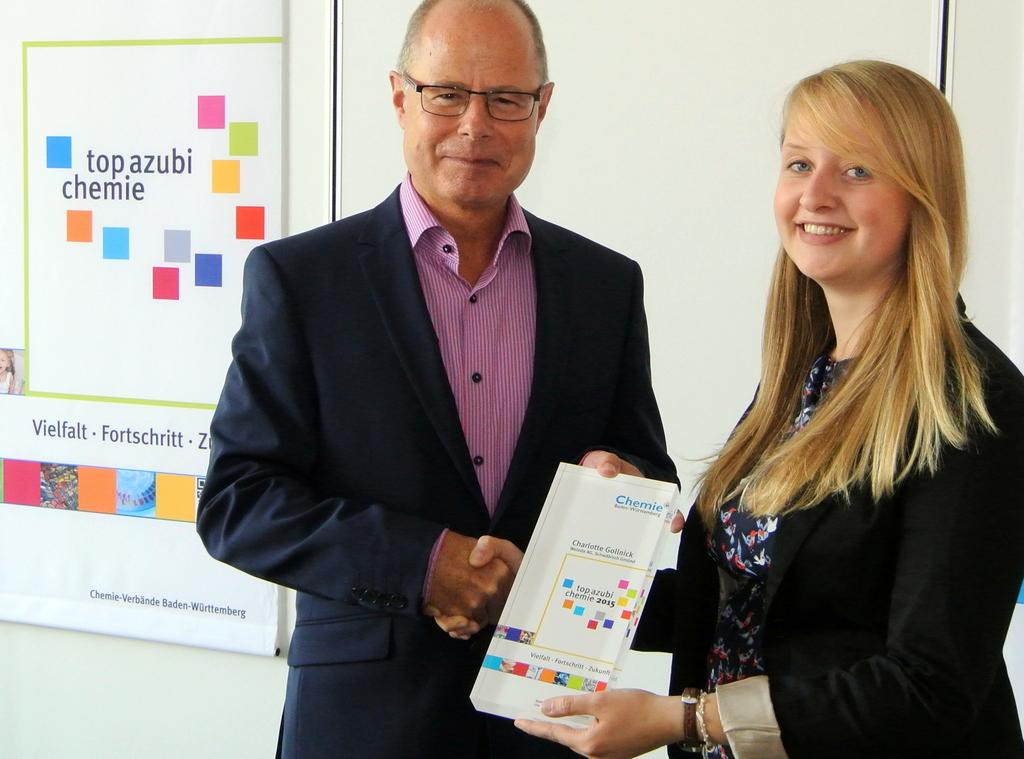How many people are in the image? There are two people in the image. What are the two people doing in the image? The two people are holding a board and shaking hands. What is the expression on the faces of the two people? The two people are smiling. Where is the board located in the image? The board is on a wall. What can be seen on the board? There are colorful cubes, pictures, and writing on the board. Can you see any ocean, leaf, or cherries in the image? No, there is no ocean, leaf, or cherries present in the image. 